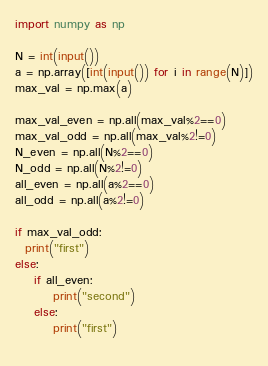<code> <loc_0><loc_0><loc_500><loc_500><_Python_>import numpy as np

N = int(input())
a = np.array([int(input()) for i in range(N)])
max_val = np.max(a)

max_val_even = np.all(max_val%2==0)
max_val_odd = np.all(max_val%2!=0)
N_even = np.all(N%2==0)
N_odd = np.all(N%2!=0)
all_even = np.all(a%2==0)
all_odd = np.all(a%2!=0)

if max_val_odd:
  print("first")
else:
	if all_even:
	  	print("second")
	else:
 		print("first")
  

</code> 